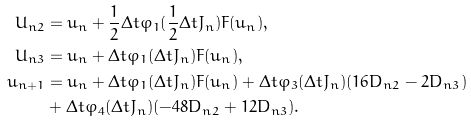<formula> <loc_0><loc_0><loc_500><loc_500>U _ { n 2 } & = u _ { n } + \frac { 1 } { 2 } \Delta t \varphi _ { 1 } ( \frac { 1 } { 2 } \Delta t J _ { n } ) F ( u _ { n } ) , \\ U _ { n 3 } & = u _ { n } + \Delta t \varphi _ { 1 } ( \Delta t J _ { n } ) F ( u _ { n } ) , \\ u _ { n + 1 } & = u _ { n } + \Delta t \varphi _ { 1 } ( \Delta t J _ { n } ) F ( u _ { n } ) + \Delta t \varphi _ { 3 } ( \Delta t J _ { n } ) ( 1 6 D _ { n 2 } - 2 D _ { n 3 } ) \\ & + \Delta t \varphi _ { 4 } ( \Delta t J _ { n } ) ( - 4 8 D _ { n 2 } + 1 2 D _ { n 3 } ) .</formula> 